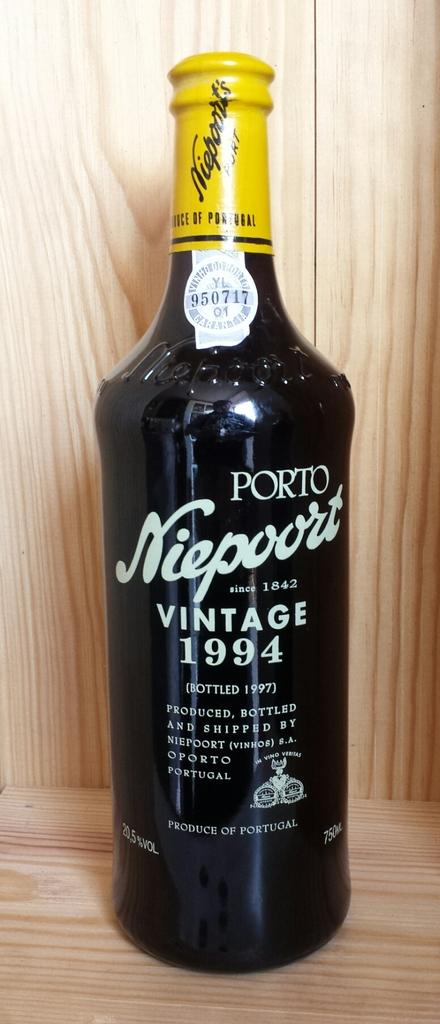<image>
Describe the image concisely. The bottled beverage shown was made in Portugal. 